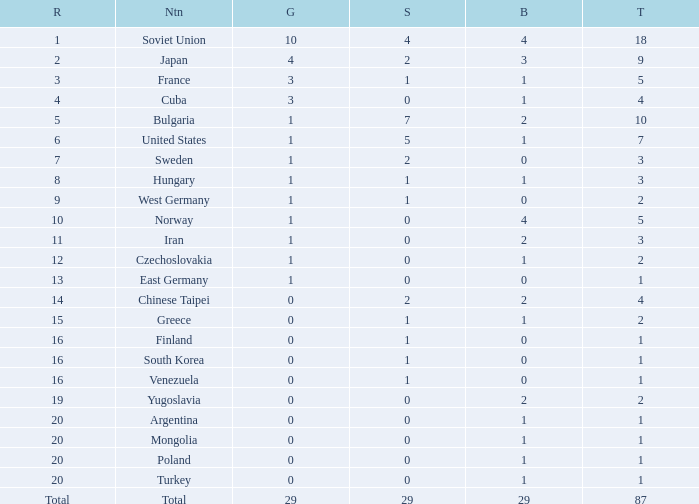What is the sum of gold medals for a rank of 14? 0.0. 